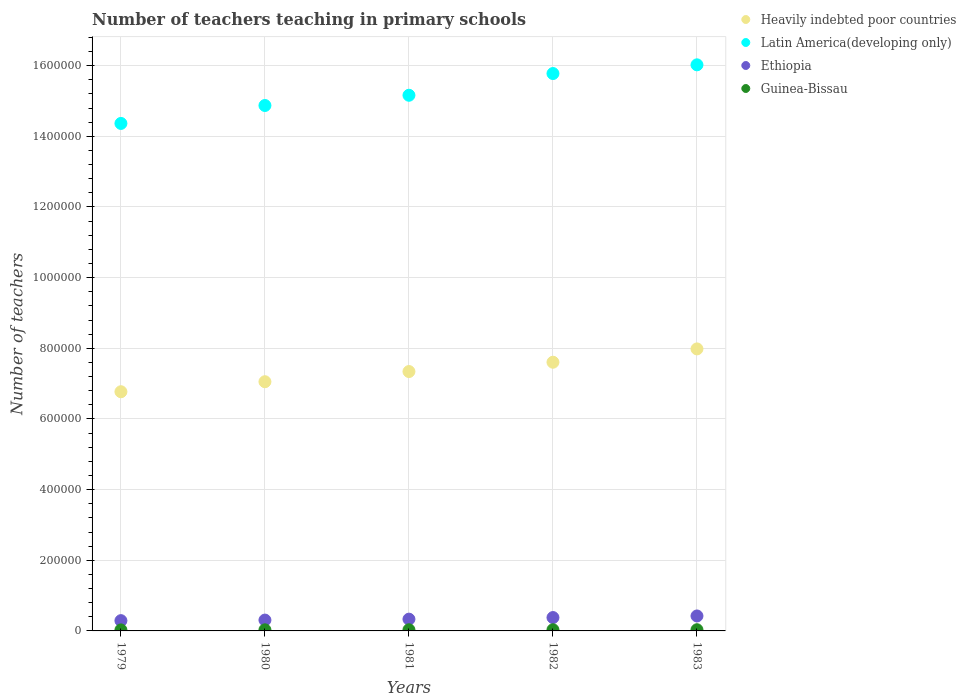How many different coloured dotlines are there?
Provide a succinct answer. 4. Is the number of dotlines equal to the number of legend labels?
Provide a succinct answer. Yes. What is the number of teachers teaching in primary schools in Heavily indebted poor countries in 1981?
Your response must be concise. 7.34e+05. Across all years, what is the maximum number of teachers teaching in primary schools in Guinea-Bissau?
Offer a very short reply. 3363. Across all years, what is the minimum number of teachers teaching in primary schools in Latin America(developing only)?
Give a very brief answer. 1.44e+06. In which year was the number of teachers teaching in primary schools in Heavily indebted poor countries maximum?
Your answer should be very brief. 1983. In which year was the number of teachers teaching in primary schools in Latin America(developing only) minimum?
Offer a terse response. 1979. What is the total number of teachers teaching in primary schools in Heavily indebted poor countries in the graph?
Your answer should be compact. 3.68e+06. What is the difference between the number of teachers teaching in primary schools in Heavily indebted poor countries in 1980 and that in 1982?
Provide a succinct answer. -5.52e+04. What is the difference between the number of teachers teaching in primary schools in Ethiopia in 1983 and the number of teachers teaching in primary schools in Heavily indebted poor countries in 1982?
Ensure brevity in your answer.  -7.18e+05. What is the average number of teachers teaching in primary schools in Guinea-Bissau per year?
Ensure brevity in your answer.  3183. In the year 1982, what is the difference between the number of teachers teaching in primary schools in Latin America(developing only) and number of teachers teaching in primary schools in Guinea-Bissau?
Your answer should be very brief. 1.57e+06. What is the ratio of the number of teachers teaching in primary schools in Guinea-Bissau in 1979 to that in 1983?
Your answer should be very brief. 0.86. Is the number of teachers teaching in primary schools in Ethiopia in 1979 less than that in 1980?
Offer a terse response. Yes. What is the difference between the highest and the second highest number of teachers teaching in primary schools in Latin America(developing only)?
Offer a very short reply. 2.47e+04. What is the difference between the highest and the lowest number of teachers teaching in primary schools in Heavily indebted poor countries?
Offer a very short reply. 1.21e+05. In how many years, is the number of teachers teaching in primary schools in Heavily indebted poor countries greater than the average number of teachers teaching in primary schools in Heavily indebted poor countries taken over all years?
Make the answer very short. 2. Is the sum of the number of teachers teaching in primary schools in Latin America(developing only) in 1981 and 1983 greater than the maximum number of teachers teaching in primary schools in Ethiopia across all years?
Keep it short and to the point. Yes. Is the number of teachers teaching in primary schools in Heavily indebted poor countries strictly greater than the number of teachers teaching in primary schools in Guinea-Bissau over the years?
Keep it short and to the point. Yes. How many dotlines are there?
Offer a very short reply. 4. How many years are there in the graph?
Ensure brevity in your answer.  5. What is the difference between two consecutive major ticks on the Y-axis?
Your response must be concise. 2.00e+05. Are the values on the major ticks of Y-axis written in scientific E-notation?
Keep it short and to the point. No. Where does the legend appear in the graph?
Offer a terse response. Top right. How many legend labels are there?
Make the answer very short. 4. How are the legend labels stacked?
Provide a short and direct response. Vertical. What is the title of the graph?
Your answer should be very brief. Number of teachers teaching in primary schools. What is the label or title of the Y-axis?
Your response must be concise. Number of teachers. What is the Number of teachers of Heavily indebted poor countries in 1979?
Provide a short and direct response. 6.77e+05. What is the Number of teachers of Latin America(developing only) in 1979?
Ensure brevity in your answer.  1.44e+06. What is the Number of teachers of Ethiopia in 1979?
Your answer should be very brief. 2.91e+04. What is the Number of teachers of Guinea-Bissau in 1979?
Provide a succinct answer. 2878. What is the Number of teachers of Heavily indebted poor countries in 1980?
Offer a terse response. 7.05e+05. What is the Number of teachers of Latin America(developing only) in 1980?
Give a very brief answer. 1.49e+06. What is the Number of teachers of Ethiopia in 1980?
Provide a short and direct response. 3.07e+04. What is the Number of teachers in Guinea-Bissau in 1980?
Your answer should be very brief. 3102. What is the Number of teachers of Heavily indebted poor countries in 1981?
Provide a succinct answer. 7.34e+05. What is the Number of teachers of Latin America(developing only) in 1981?
Give a very brief answer. 1.52e+06. What is the Number of teachers of Ethiopia in 1981?
Your answer should be compact. 3.33e+04. What is the Number of teachers of Guinea-Bissau in 1981?
Your response must be concise. 3257. What is the Number of teachers of Heavily indebted poor countries in 1982?
Provide a short and direct response. 7.61e+05. What is the Number of teachers in Latin America(developing only) in 1982?
Make the answer very short. 1.58e+06. What is the Number of teachers in Ethiopia in 1982?
Ensure brevity in your answer.  3.79e+04. What is the Number of teachers of Guinea-Bissau in 1982?
Provide a succinct answer. 3315. What is the Number of teachers in Heavily indebted poor countries in 1983?
Your response must be concise. 7.98e+05. What is the Number of teachers in Latin America(developing only) in 1983?
Your answer should be very brief. 1.60e+06. What is the Number of teachers in Ethiopia in 1983?
Ensure brevity in your answer.  4.23e+04. What is the Number of teachers in Guinea-Bissau in 1983?
Give a very brief answer. 3363. Across all years, what is the maximum Number of teachers of Heavily indebted poor countries?
Your answer should be very brief. 7.98e+05. Across all years, what is the maximum Number of teachers in Latin America(developing only)?
Ensure brevity in your answer.  1.60e+06. Across all years, what is the maximum Number of teachers in Ethiopia?
Make the answer very short. 4.23e+04. Across all years, what is the maximum Number of teachers in Guinea-Bissau?
Offer a terse response. 3363. Across all years, what is the minimum Number of teachers in Heavily indebted poor countries?
Provide a succinct answer. 6.77e+05. Across all years, what is the minimum Number of teachers in Latin America(developing only)?
Provide a short and direct response. 1.44e+06. Across all years, what is the minimum Number of teachers in Ethiopia?
Give a very brief answer. 2.91e+04. Across all years, what is the minimum Number of teachers of Guinea-Bissau?
Provide a succinct answer. 2878. What is the total Number of teachers in Heavily indebted poor countries in the graph?
Your response must be concise. 3.68e+06. What is the total Number of teachers of Latin America(developing only) in the graph?
Your answer should be very brief. 7.62e+06. What is the total Number of teachers of Ethiopia in the graph?
Provide a succinct answer. 1.73e+05. What is the total Number of teachers of Guinea-Bissau in the graph?
Your answer should be compact. 1.59e+04. What is the difference between the Number of teachers of Heavily indebted poor countries in 1979 and that in 1980?
Offer a very short reply. -2.84e+04. What is the difference between the Number of teachers in Latin America(developing only) in 1979 and that in 1980?
Provide a succinct answer. -5.08e+04. What is the difference between the Number of teachers in Ethiopia in 1979 and that in 1980?
Give a very brief answer. -1608. What is the difference between the Number of teachers of Guinea-Bissau in 1979 and that in 1980?
Offer a terse response. -224. What is the difference between the Number of teachers in Heavily indebted poor countries in 1979 and that in 1981?
Your answer should be compact. -5.72e+04. What is the difference between the Number of teachers of Latin America(developing only) in 1979 and that in 1981?
Keep it short and to the point. -7.98e+04. What is the difference between the Number of teachers of Ethiopia in 1979 and that in 1981?
Your answer should be very brief. -4243. What is the difference between the Number of teachers in Guinea-Bissau in 1979 and that in 1981?
Give a very brief answer. -379. What is the difference between the Number of teachers of Heavily indebted poor countries in 1979 and that in 1982?
Provide a short and direct response. -8.35e+04. What is the difference between the Number of teachers in Latin America(developing only) in 1979 and that in 1982?
Your response must be concise. -1.41e+05. What is the difference between the Number of teachers of Ethiopia in 1979 and that in 1982?
Offer a terse response. -8775. What is the difference between the Number of teachers of Guinea-Bissau in 1979 and that in 1982?
Keep it short and to the point. -437. What is the difference between the Number of teachers of Heavily indebted poor countries in 1979 and that in 1983?
Give a very brief answer. -1.21e+05. What is the difference between the Number of teachers of Latin America(developing only) in 1979 and that in 1983?
Offer a very short reply. -1.66e+05. What is the difference between the Number of teachers in Ethiopia in 1979 and that in 1983?
Provide a short and direct response. -1.33e+04. What is the difference between the Number of teachers in Guinea-Bissau in 1979 and that in 1983?
Your response must be concise. -485. What is the difference between the Number of teachers in Heavily indebted poor countries in 1980 and that in 1981?
Your answer should be compact. -2.88e+04. What is the difference between the Number of teachers in Latin America(developing only) in 1980 and that in 1981?
Offer a very short reply. -2.90e+04. What is the difference between the Number of teachers of Ethiopia in 1980 and that in 1981?
Your answer should be very brief. -2635. What is the difference between the Number of teachers in Guinea-Bissau in 1980 and that in 1981?
Offer a terse response. -155. What is the difference between the Number of teachers of Heavily indebted poor countries in 1980 and that in 1982?
Make the answer very short. -5.52e+04. What is the difference between the Number of teachers in Latin America(developing only) in 1980 and that in 1982?
Offer a very short reply. -9.04e+04. What is the difference between the Number of teachers in Ethiopia in 1980 and that in 1982?
Your response must be concise. -7167. What is the difference between the Number of teachers of Guinea-Bissau in 1980 and that in 1982?
Provide a succinct answer. -213. What is the difference between the Number of teachers in Heavily indebted poor countries in 1980 and that in 1983?
Offer a very short reply. -9.29e+04. What is the difference between the Number of teachers in Latin America(developing only) in 1980 and that in 1983?
Provide a succinct answer. -1.15e+05. What is the difference between the Number of teachers of Ethiopia in 1980 and that in 1983?
Ensure brevity in your answer.  -1.17e+04. What is the difference between the Number of teachers of Guinea-Bissau in 1980 and that in 1983?
Your response must be concise. -261. What is the difference between the Number of teachers in Heavily indebted poor countries in 1981 and that in 1982?
Keep it short and to the point. -2.64e+04. What is the difference between the Number of teachers of Latin America(developing only) in 1981 and that in 1982?
Provide a short and direct response. -6.15e+04. What is the difference between the Number of teachers of Ethiopia in 1981 and that in 1982?
Give a very brief answer. -4532. What is the difference between the Number of teachers in Guinea-Bissau in 1981 and that in 1982?
Keep it short and to the point. -58. What is the difference between the Number of teachers of Heavily indebted poor countries in 1981 and that in 1983?
Your answer should be very brief. -6.41e+04. What is the difference between the Number of teachers of Latin America(developing only) in 1981 and that in 1983?
Give a very brief answer. -8.61e+04. What is the difference between the Number of teachers of Ethiopia in 1981 and that in 1983?
Provide a succinct answer. -9025. What is the difference between the Number of teachers of Guinea-Bissau in 1981 and that in 1983?
Your response must be concise. -106. What is the difference between the Number of teachers in Heavily indebted poor countries in 1982 and that in 1983?
Offer a terse response. -3.77e+04. What is the difference between the Number of teachers in Latin America(developing only) in 1982 and that in 1983?
Ensure brevity in your answer.  -2.47e+04. What is the difference between the Number of teachers of Ethiopia in 1982 and that in 1983?
Your answer should be compact. -4493. What is the difference between the Number of teachers in Guinea-Bissau in 1982 and that in 1983?
Provide a succinct answer. -48. What is the difference between the Number of teachers of Heavily indebted poor countries in 1979 and the Number of teachers of Latin America(developing only) in 1980?
Offer a terse response. -8.10e+05. What is the difference between the Number of teachers in Heavily indebted poor countries in 1979 and the Number of teachers in Ethiopia in 1980?
Ensure brevity in your answer.  6.46e+05. What is the difference between the Number of teachers in Heavily indebted poor countries in 1979 and the Number of teachers in Guinea-Bissau in 1980?
Your response must be concise. 6.74e+05. What is the difference between the Number of teachers of Latin America(developing only) in 1979 and the Number of teachers of Ethiopia in 1980?
Offer a terse response. 1.41e+06. What is the difference between the Number of teachers in Latin America(developing only) in 1979 and the Number of teachers in Guinea-Bissau in 1980?
Provide a succinct answer. 1.43e+06. What is the difference between the Number of teachers in Ethiopia in 1979 and the Number of teachers in Guinea-Bissau in 1980?
Offer a terse response. 2.60e+04. What is the difference between the Number of teachers in Heavily indebted poor countries in 1979 and the Number of teachers in Latin America(developing only) in 1981?
Your response must be concise. -8.39e+05. What is the difference between the Number of teachers in Heavily indebted poor countries in 1979 and the Number of teachers in Ethiopia in 1981?
Offer a very short reply. 6.44e+05. What is the difference between the Number of teachers in Heavily indebted poor countries in 1979 and the Number of teachers in Guinea-Bissau in 1981?
Offer a terse response. 6.74e+05. What is the difference between the Number of teachers in Latin America(developing only) in 1979 and the Number of teachers in Ethiopia in 1981?
Give a very brief answer. 1.40e+06. What is the difference between the Number of teachers of Latin America(developing only) in 1979 and the Number of teachers of Guinea-Bissau in 1981?
Provide a succinct answer. 1.43e+06. What is the difference between the Number of teachers of Ethiopia in 1979 and the Number of teachers of Guinea-Bissau in 1981?
Give a very brief answer. 2.58e+04. What is the difference between the Number of teachers in Heavily indebted poor countries in 1979 and the Number of teachers in Latin America(developing only) in 1982?
Provide a succinct answer. -9.01e+05. What is the difference between the Number of teachers in Heavily indebted poor countries in 1979 and the Number of teachers in Ethiopia in 1982?
Keep it short and to the point. 6.39e+05. What is the difference between the Number of teachers in Heavily indebted poor countries in 1979 and the Number of teachers in Guinea-Bissau in 1982?
Ensure brevity in your answer.  6.74e+05. What is the difference between the Number of teachers in Latin America(developing only) in 1979 and the Number of teachers in Ethiopia in 1982?
Make the answer very short. 1.40e+06. What is the difference between the Number of teachers of Latin America(developing only) in 1979 and the Number of teachers of Guinea-Bissau in 1982?
Provide a short and direct response. 1.43e+06. What is the difference between the Number of teachers of Ethiopia in 1979 and the Number of teachers of Guinea-Bissau in 1982?
Ensure brevity in your answer.  2.58e+04. What is the difference between the Number of teachers of Heavily indebted poor countries in 1979 and the Number of teachers of Latin America(developing only) in 1983?
Make the answer very short. -9.25e+05. What is the difference between the Number of teachers in Heavily indebted poor countries in 1979 and the Number of teachers in Ethiopia in 1983?
Offer a very short reply. 6.35e+05. What is the difference between the Number of teachers of Heavily indebted poor countries in 1979 and the Number of teachers of Guinea-Bissau in 1983?
Offer a terse response. 6.74e+05. What is the difference between the Number of teachers of Latin America(developing only) in 1979 and the Number of teachers of Ethiopia in 1983?
Offer a very short reply. 1.39e+06. What is the difference between the Number of teachers in Latin America(developing only) in 1979 and the Number of teachers in Guinea-Bissau in 1983?
Your answer should be very brief. 1.43e+06. What is the difference between the Number of teachers in Ethiopia in 1979 and the Number of teachers in Guinea-Bissau in 1983?
Your response must be concise. 2.57e+04. What is the difference between the Number of teachers of Heavily indebted poor countries in 1980 and the Number of teachers of Latin America(developing only) in 1981?
Make the answer very short. -8.11e+05. What is the difference between the Number of teachers of Heavily indebted poor countries in 1980 and the Number of teachers of Ethiopia in 1981?
Your answer should be compact. 6.72e+05. What is the difference between the Number of teachers of Heavily indebted poor countries in 1980 and the Number of teachers of Guinea-Bissau in 1981?
Ensure brevity in your answer.  7.02e+05. What is the difference between the Number of teachers of Latin America(developing only) in 1980 and the Number of teachers of Ethiopia in 1981?
Give a very brief answer. 1.45e+06. What is the difference between the Number of teachers in Latin America(developing only) in 1980 and the Number of teachers in Guinea-Bissau in 1981?
Ensure brevity in your answer.  1.48e+06. What is the difference between the Number of teachers in Ethiopia in 1980 and the Number of teachers in Guinea-Bissau in 1981?
Offer a terse response. 2.74e+04. What is the difference between the Number of teachers in Heavily indebted poor countries in 1980 and the Number of teachers in Latin America(developing only) in 1982?
Make the answer very short. -8.72e+05. What is the difference between the Number of teachers in Heavily indebted poor countries in 1980 and the Number of teachers in Ethiopia in 1982?
Your response must be concise. 6.68e+05. What is the difference between the Number of teachers of Heavily indebted poor countries in 1980 and the Number of teachers of Guinea-Bissau in 1982?
Keep it short and to the point. 7.02e+05. What is the difference between the Number of teachers in Latin America(developing only) in 1980 and the Number of teachers in Ethiopia in 1982?
Offer a very short reply. 1.45e+06. What is the difference between the Number of teachers in Latin America(developing only) in 1980 and the Number of teachers in Guinea-Bissau in 1982?
Provide a short and direct response. 1.48e+06. What is the difference between the Number of teachers in Ethiopia in 1980 and the Number of teachers in Guinea-Bissau in 1982?
Your answer should be compact. 2.74e+04. What is the difference between the Number of teachers in Heavily indebted poor countries in 1980 and the Number of teachers in Latin America(developing only) in 1983?
Provide a short and direct response. -8.97e+05. What is the difference between the Number of teachers of Heavily indebted poor countries in 1980 and the Number of teachers of Ethiopia in 1983?
Provide a short and direct response. 6.63e+05. What is the difference between the Number of teachers of Heavily indebted poor countries in 1980 and the Number of teachers of Guinea-Bissau in 1983?
Offer a terse response. 7.02e+05. What is the difference between the Number of teachers of Latin America(developing only) in 1980 and the Number of teachers of Ethiopia in 1983?
Offer a terse response. 1.44e+06. What is the difference between the Number of teachers of Latin America(developing only) in 1980 and the Number of teachers of Guinea-Bissau in 1983?
Your response must be concise. 1.48e+06. What is the difference between the Number of teachers in Ethiopia in 1980 and the Number of teachers in Guinea-Bissau in 1983?
Offer a very short reply. 2.73e+04. What is the difference between the Number of teachers of Heavily indebted poor countries in 1981 and the Number of teachers of Latin America(developing only) in 1982?
Offer a very short reply. -8.43e+05. What is the difference between the Number of teachers in Heavily indebted poor countries in 1981 and the Number of teachers in Ethiopia in 1982?
Provide a succinct answer. 6.96e+05. What is the difference between the Number of teachers of Heavily indebted poor countries in 1981 and the Number of teachers of Guinea-Bissau in 1982?
Offer a terse response. 7.31e+05. What is the difference between the Number of teachers of Latin America(developing only) in 1981 and the Number of teachers of Ethiopia in 1982?
Provide a succinct answer. 1.48e+06. What is the difference between the Number of teachers in Latin America(developing only) in 1981 and the Number of teachers in Guinea-Bissau in 1982?
Provide a short and direct response. 1.51e+06. What is the difference between the Number of teachers in Ethiopia in 1981 and the Number of teachers in Guinea-Bissau in 1982?
Ensure brevity in your answer.  3.00e+04. What is the difference between the Number of teachers in Heavily indebted poor countries in 1981 and the Number of teachers in Latin America(developing only) in 1983?
Your answer should be compact. -8.68e+05. What is the difference between the Number of teachers in Heavily indebted poor countries in 1981 and the Number of teachers in Ethiopia in 1983?
Provide a short and direct response. 6.92e+05. What is the difference between the Number of teachers of Heavily indebted poor countries in 1981 and the Number of teachers of Guinea-Bissau in 1983?
Offer a very short reply. 7.31e+05. What is the difference between the Number of teachers of Latin America(developing only) in 1981 and the Number of teachers of Ethiopia in 1983?
Your answer should be very brief. 1.47e+06. What is the difference between the Number of teachers in Latin America(developing only) in 1981 and the Number of teachers in Guinea-Bissau in 1983?
Provide a succinct answer. 1.51e+06. What is the difference between the Number of teachers of Ethiopia in 1981 and the Number of teachers of Guinea-Bissau in 1983?
Make the answer very short. 3.00e+04. What is the difference between the Number of teachers in Heavily indebted poor countries in 1982 and the Number of teachers in Latin America(developing only) in 1983?
Offer a terse response. -8.42e+05. What is the difference between the Number of teachers in Heavily indebted poor countries in 1982 and the Number of teachers in Ethiopia in 1983?
Give a very brief answer. 7.18e+05. What is the difference between the Number of teachers of Heavily indebted poor countries in 1982 and the Number of teachers of Guinea-Bissau in 1983?
Provide a short and direct response. 7.57e+05. What is the difference between the Number of teachers of Latin America(developing only) in 1982 and the Number of teachers of Ethiopia in 1983?
Give a very brief answer. 1.54e+06. What is the difference between the Number of teachers of Latin America(developing only) in 1982 and the Number of teachers of Guinea-Bissau in 1983?
Provide a succinct answer. 1.57e+06. What is the difference between the Number of teachers of Ethiopia in 1982 and the Number of teachers of Guinea-Bissau in 1983?
Your answer should be compact. 3.45e+04. What is the average Number of teachers of Heavily indebted poor countries per year?
Give a very brief answer. 7.35e+05. What is the average Number of teachers of Latin America(developing only) per year?
Your answer should be very brief. 1.52e+06. What is the average Number of teachers of Ethiopia per year?
Give a very brief answer. 3.47e+04. What is the average Number of teachers of Guinea-Bissau per year?
Offer a terse response. 3183. In the year 1979, what is the difference between the Number of teachers of Heavily indebted poor countries and Number of teachers of Latin America(developing only)?
Ensure brevity in your answer.  -7.59e+05. In the year 1979, what is the difference between the Number of teachers of Heavily indebted poor countries and Number of teachers of Ethiopia?
Provide a succinct answer. 6.48e+05. In the year 1979, what is the difference between the Number of teachers in Heavily indebted poor countries and Number of teachers in Guinea-Bissau?
Give a very brief answer. 6.74e+05. In the year 1979, what is the difference between the Number of teachers of Latin America(developing only) and Number of teachers of Ethiopia?
Provide a short and direct response. 1.41e+06. In the year 1979, what is the difference between the Number of teachers of Latin America(developing only) and Number of teachers of Guinea-Bissau?
Your answer should be very brief. 1.43e+06. In the year 1979, what is the difference between the Number of teachers in Ethiopia and Number of teachers in Guinea-Bissau?
Your answer should be compact. 2.62e+04. In the year 1980, what is the difference between the Number of teachers of Heavily indebted poor countries and Number of teachers of Latin America(developing only)?
Your answer should be compact. -7.82e+05. In the year 1980, what is the difference between the Number of teachers of Heavily indebted poor countries and Number of teachers of Ethiopia?
Keep it short and to the point. 6.75e+05. In the year 1980, what is the difference between the Number of teachers in Heavily indebted poor countries and Number of teachers in Guinea-Bissau?
Provide a short and direct response. 7.02e+05. In the year 1980, what is the difference between the Number of teachers of Latin America(developing only) and Number of teachers of Ethiopia?
Make the answer very short. 1.46e+06. In the year 1980, what is the difference between the Number of teachers in Latin America(developing only) and Number of teachers in Guinea-Bissau?
Keep it short and to the point. 1.48e+06. In the year 1980, what is the difference between the Number of teachers in Ethiopia and Number of teachers in Guinea-Bissau?
Offer a terse response. 2.76e+04. In the year 1981, what is the difference between the Number of teachers in Heavily indebted poor countries and Number of teachers in Latin America(developing only)?
Give a very brief answer. -7.82e+05. In the year 1981, what is the difference between the Number of teachers in Heavily indebted poor countries and Number of teachers in Ethiopia?
Your response must be concise. 7.01e+05. In the year 1981, what is the difference between the Number of teachers of Heavily indebted poor countries and Number of teachers of Guinea-Bissau?
Your answer should be compact. 7.31e+05. In the year 1981, what is the difference between the Number of teachers of Latin America(developing only) and Number of teachers of Ethiopia?
Make the answer very short. 1.48e+06. In the year 1981, what is the difference between the Number of teachers in Latin America(developing only) and Number of teachers in Guinea-Bissau?
Make the answer very short. 1.51e+06. In the year 1981, what is the difference between the Number of teachers of Ethiopia and Number of teachers of Guinea-Bissau?
Offer a terse response. 3.01e+04. In the year 1982, what is the difference between the Number of teachers in Heavily indebted poor countries and Number of teachers in Latin America(developing only)?
Your answer should be compact. -8.17e+05. In the year 1982, what is the difference between the Number of teachers of Heavily indebted poor countries and Number of teachers of Ethiopia?
Provide a succinct answer. 7.23e+05. In the year 1982, what is the difference between the Number of teachers of Heavily indebted poor countries and Number of teachers of Guinea-Bissau?
Provide a succinct answer. 7.57e+05. In the year 1982, what is the difference between the Number of teachers in Latin America(developing only) and Number of teachers in Ethiopia?
Your answer should be compact. 1.54e+06. In the year 1982, what is the difference between the Number of teachers in Latin America(developing only) and Number of teachers in Guinea-Bissau?
Provide a succinct answer. 1.57e+06. In the year 1982, what is the difference between the Number of teachers of Ethiopia and Number of teachers of Guinea-Bissau?
Keep it short and to the point. 3.45e+04. In the year 1983, what is the difference between the Number of teachers of Heavily indebted poor countries and Number of teachers of Latin America(developing only)?
Make the answer very short. -8.04e+05. In the year 1983, what is the difference between the Number of teachers of Heavily indebted poor countries and Number of teachers of Ethiopia?
Your answer should be compact. 7.56e+05. In the year 1983, what is the difference between the Number of teachers of Heavily indebted poor countries and Number of teachers of Guinea-Bissau?
Give a very brief answer. 7.95e+05. In the year 1983, what is the difference between the Number of teachers of Latin America(developing only) and Number of teachers of Ethiopia?
Your response must be concise. 1.56e+06. In the year 1983, what is the difference between the Number of teachers of Latin America(developing only) and Number of teachers of Guinea-Bissau?
Your answer should be compact. 1.60e+06. In the year 1983, what is the difference between the Number of teachers in Ethiopia and Number of teachers in Guinea-Bissau?
Offer a terse response. 3.90e+04. What is the ratio of the Number of teachers of Heavily indebted poor countries in 1979 to that in 1980?
Make the answer very short. 0.96. What is the ratio of the Number of teachers in Latin America(developing only) in 1979 to that in 1980?
Make the answer very short. 0.97. What is the ratio of the Number of teachers of Ethiopia in 1979 to that in 1980?
Make the answer very short. 0.95. What is the ratio of the Number of teachers of Guinea-Bissau in 1979 to that in 1980?
Ensure brevity in your answer.  0.93. What is the ratio of the Number of teachers of Heavily indebted poor countries in 1979 to that in 1981?
Your response must be concise. 0.92. What is the ratio of the Number of teachers of Ethiopia in 1979 to that in 1981?
Your response must be concise. 0.87. What is the ratio of the Number of teachers in Guinea-Bissau in 1979 to that in 1981?
Your response must be concise. 0.88. What is the ratio of the Number of teachers in Heavily indebted poor countries in 1979 to that in 1982?
Your answer should be compact. 0.89. What is the ratio of the Number of teachers in Latin America(developing only) in 1979 to that in 1982?
Ensure brevity in your answer.  0.91. What is the ratio of the Number of teachers of Ethiopia in 1979 to that in 1982?
Give a very brief answer. 0.77. What is the ratio of the Number of teachers of Guinea-Bissau in 1979 to that in 1982?
Your answer should be compact. 0.87. What is the ratio of the Number of teachers of Heavily indebted poor countries in 1979 to that in 1983?
Give a very brief answer. 0.85. What is the ratio of the Number of teachers in Latin America(developing only) in 1979 to that in 1983?
Offer a very short reply. 0.9. What is the ratio of the Number of teachers of Ethiopia in 1979 to that in 1983?
Provide a succinct answer. 0.69. What is the ratio of the Number of teachers of Guinea-Bissau in 1979 to that in 1983?
Offer a terse response. 0.86. What is the ratio of the Number of teachers of Heavily indebted poor countries in 1980 to that in 1981?
Your answer should be compact. 0.96. What is the ratio of the Number of teachers of Latin America(developing only) in 1980 to that in 1981?
Give a very brief answer. 0.98. What is the ratio of the Number of teachers of Ethiopia in 1980 to that in 1981?
Provide a short and direct response. 0.92. What is the ratio of the Number of teachers in Heavily indebted poor countries in 1980 to that in 1982?
Make the answer very short. 0.93. What is the ratio of the Number of teachers in Latin America(developing only) in 1980 to that in 1982?
Make the answer very short. 0.94. What is the ratio of the Number of teachers of Ethiopia in 1980 to that in 1982?
Keep it short and to the point. 0.81. What is the ratio of the Number of teachers of Guinea-Bissau in 1980 to that in 1982?
Offer a terse response. 0.94. What is the ratio of the Number of teachers in Heavily indebted poor countries in 1980 to that in 1983?
Give a very brief answer. 0.88. What is the ratio of the Number of teachers of Latin America(developing only) in 1980 to that in 1983?
Keep it short and to the point. 0.93. What is the ratio of the Number of teachers of Ethiopia in 1980 to that in 1983?
Offer a very short reply. 0.72. What is the ratio of the Number of teachers of Guinea-Bissau in 1980 to that in 1983?
Offer a very short reply. 0.92. What is the ratio of the Number of teachers in Heavily indebted poor countries in 1981 to that in 1982?
Offer a terse response. 0.97. What is the ratio of the Number of teachers in Latin America(developing only) in 1981 to that in 1982?
Make the answer very short. 0.96. What is the ratio of the Number of teachers in Ethiopia in 1981 to that in 1982?
Offer a terse response. 0.88. What is the ratio of the Number of teachers of Guinea-Bissau in 1981 to that in 1982?
Give a very brief answer. 0.98. What is the ratio of the Number of teachers of Heavily indebted poor countries in 1981 to that in 1983?
Offer a very short reply. 0.92. What is the ratio of the Number of teachers of Latin America(developing only) in 1981 to that in 1983?
Offer a very short reply. 0.95. What is the ratio of the Number of teachers in Ethiopia in 1981 to that in 1983?
Keep it short and to the point. 0.79. What is the ratio of the Number of teachers in Guinea-Bissau in 1981 to that in 1983?
Keep it short and to the point. 0.97. What is the ratio of the Number of teachers of Heavily indebted poor countries in 1982 to that in 1983?
Your answer should be very brief. 0.95. What is the ratio of the Number of teachers of Latin America(developing only) in 1982 to that in 1983?
Your answer should be compact. 0.98. What is the ratio of the Number of teachers of Ethiopia in 1982 to that in 1983?
Provide a succinct answer. 0.89. What is the ratio of the Number of teachers of Guinea-Bissau in 1982 to that in 1983?
Provide a succinct answer. 0.99. What is the difference between the highest and the second highest Number of teachers in Heavily indebted poor countries?
Offer a terse response. 3.77e+04. What is the difference between the highest and the second highest Number of teachers in Latin America(developing only)?
Ensure brevity in your answer.  2.47e+04. What is the difference between the highest and the second highest Number of teachers of Ethiopia?
Your response must be concise. 4493. What is the difference between the highest and the second highest Number of teachers in Guinea-Bissau?
Your response must be concise. 48. What is the difference between the highest and the lowest Number of teachers in Heavily indebted poor countries?
Keep it short and to the point. 1.21e+05. What is the difference between the highest and the lowest Number of teachers in Latin America(developing only)?
Make the answer very short. 1.66e+05. What is the difference between the highest and the lowest Number of teachers in Ethiopia?
Your answer should be very brief. 1.33e+04. What is the difference between the highest and the lowest Number of teachers of Guinea-Bissau?
Ensure brevity in your answer.  485. 